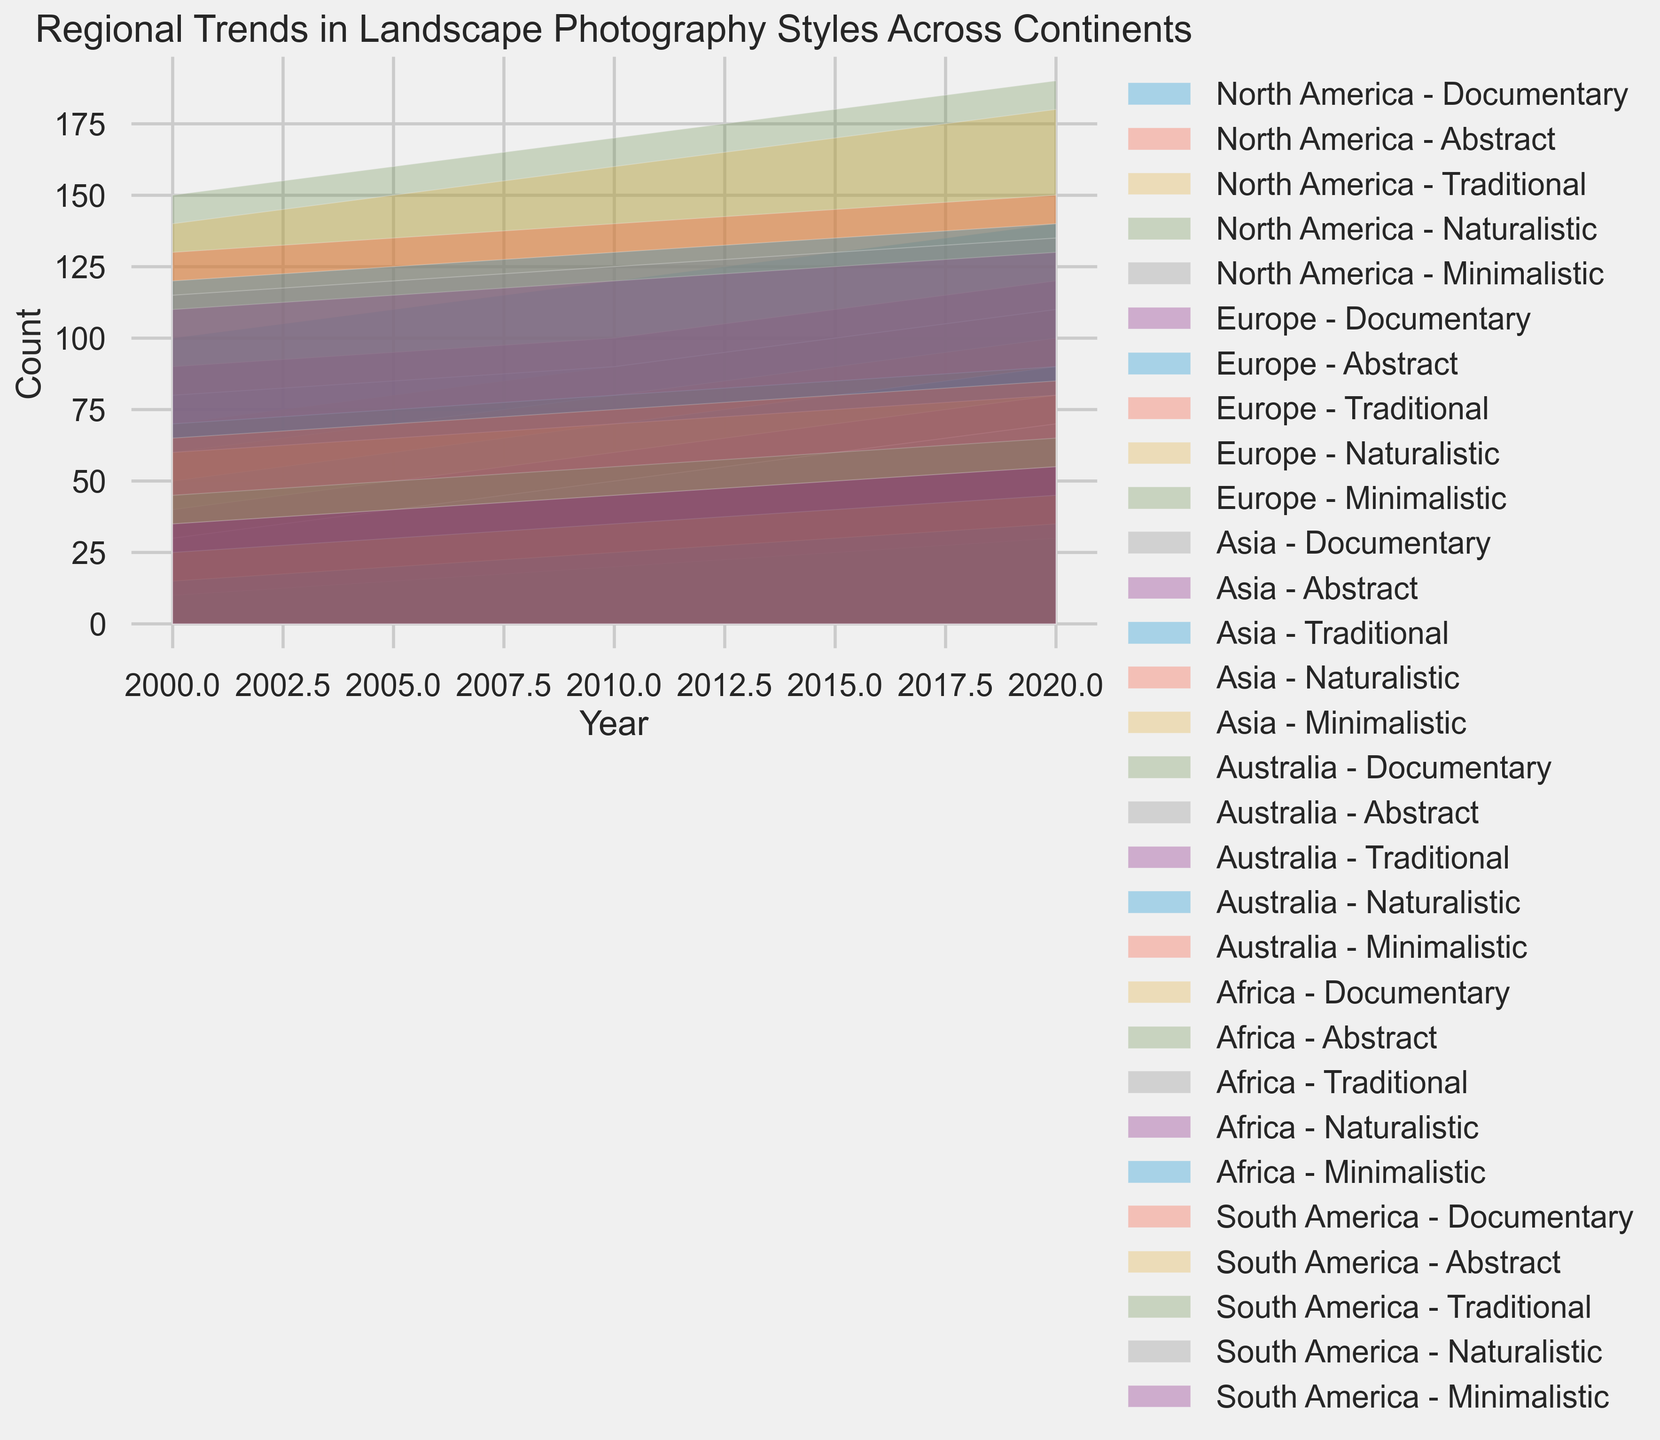What continent shows the highest count of Documentary-style landscape photography in 2020? To answer this, look at the area chart for Documentary style in 2020 across all continents. Determine which color representing a continent is the tallest in 2020.
Answer: North America Which style of photography has consistently been the most popular in Europe from 2000 to 2020? Observe the height of each area representing different styles in Europe from 2000 to 2020. Determine which style consistently has the highest count across all years.
Answer: Naturalistic By how much has the count of Minimalistic-style landscape photography increased in Africa from 2000 to 2020? Find the height represented by Minimalistic style in Africa in 2000 and 2020. Subtract the 2000 value from the 2020 value. Use the chart's scale to deduce exact values.
Answer: 25 Compare the growth in Traditional-style landscape photography between Asia and South America from 2000 to 2020. Which continent showed greater growth? Calculate the difference in counts for Traditional style from 2000 to 2020 for both Asia and South America. Compare the increments to determine the greater one.
Answer: Asia Which continent saw the least increase in Abstract-style landscape photography from 2000 to 2020? Evaluate the heights of Abstract style areas for each continent in 2000 and 2020. Compute the increase for all, then determine the smallest increment.
Answer: Africa What was the count of Naturalistic-style landscape photography in North America in 2010? Look at the corresponding area for Naturalistic style in North America in 2010 and use the chart's scale to read off the value accurately.
Answer: 170 How does the trend in Documentary-style landscape photography in Australia compare with that in South America from 2000 to 2020? Analyze the growth trend lines for Documentary style in both continents from 2000 to 2020. Check if they are increasing, decreasing, or have any specific patterns.
Answer: Both increase Which style of landscape photography has grown the most in North America from 2000 to 2020? Calculate the difference in counts for all styles in North America from 2000 to 2020. The style with the largest difference is the one that has grown the most.
Answer: Naturalistic 